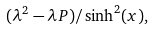<formula> <loc_0><loc_0><loc_500><loc_500>( \lambda ^ { 2 } - \lambda P ) / \sinh ^ { 2 } ( x ) ,</formula> 